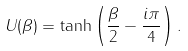<formula> <loc_0><loc_0><loc_500><loc_500>U ( \beta ) = \tanh \left ( \frac { \beta } { 2 } - \frac { i \pi } { 4 } \right ) .</formula> 